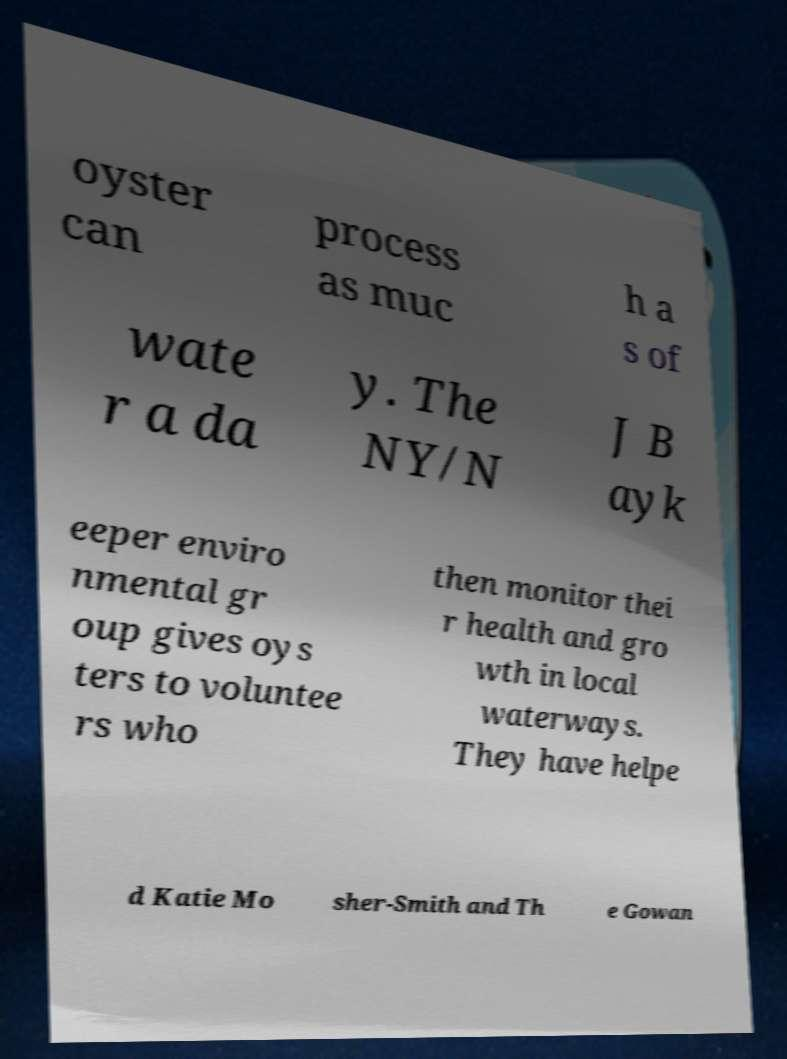For documentation purposes, I need the text within this image transcribed. Could you provide that? oyster can process as muc h a s of wate r a da y. The NY/N J B ayk eeper enviro nmental gr oup gives oys ters to voluntee rs who then monitor thei r health and gro wth in local waterways. They have helpe d Katie Mo sher-Smith and Th e Gowan 